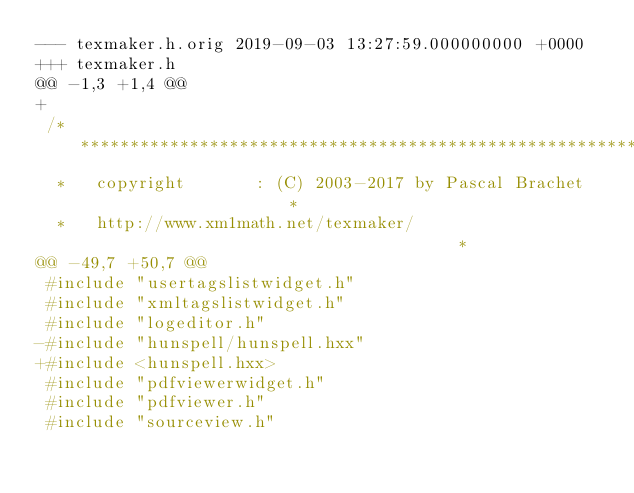<code> <loc_0><loc_0><loc_500><loc_500><_C_>--- texmaker.h.orig	2019-09-03 13:27:59.000000000 +0000
+++ texmaker.h
@@ -1,3 +1,4 @@
+
 /***************************************************************************
  *   copyright       : (C) 2003-2017 by Pascal Brachet                     *
  *   http://www.xm1math.net/texmaker/                                      *
@@ -49,7 +50,7 @@
 #include "usertagslistwidget.h"
 #include "xmltagslistwidget.h"
 #include "logeditor.h"
-#include "hunspell/hunspell.hxx"
+#include <hunspell.hxx>
 #include "pdfviewerwidget.h"
 #include "pdfviewer.h"
 #include "sourceview.h"
</code> 